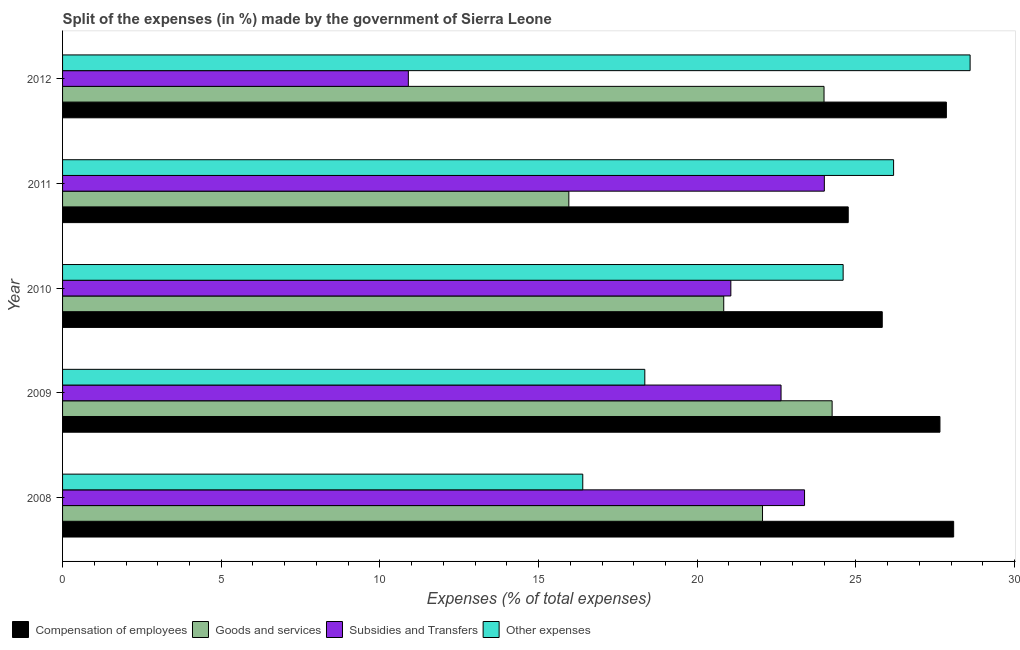How many bars are there on the 2nd tick from the bottom?
Give a very brief answer. 4. What is the label of the 2nd group of bars from the top?
Your answer should be compact. 2011. In how many cases, is the number of bars for a given year not equal to the number of legend labels?
Your answer should be compact. 0. What is the percentage of amount spent on other expenses in 2011?
Offer a terse response. 26.19. Across all years, what is the maximum percentage of amount spent on goods and services?
Your answer should be compact. 24.25. Across all years, what is the minimum percentage of amount spent on other expenses?
Your answer should be very brief. 16.39. In which year was the percentage of amount spent on compensation of employees maximum?
Offer a very short reply. 2008. What is the total percentage of amount spent on compensation of employees in the graph?
Give a very brief answer. 134.17. What is the difference between the percentage of amount spent on subsidies in 2010 and that in 2011?
Offer a very short reply. -2.95. What is the difference between the percentage of amount spent on other expenses in 2009 and the percentage of amount spent on goods and services in 2011?
Keep it short and to the point. 2.39. What is the average percentage of amount spent on goods and services per year?
Keep it short and to the point. 21.42. In the year 2008, what is the difference between the percentage of amount spent on compensation of employees and percentage of amount spent on subsidies?
Provide a short and direct response. 4.7. In how many years, is the percentage of amount spent on subsidies greater than 7 %?
Make the answer very short. 5. What is the ratio of the percentage of amount spent on other expenses in 2008 to that in 2009?
Give a very brief answer. 0.89. Is the difference between the percentage of amount spent on goods and services in 2008 and 2012 greater than the difference between the percentage of amount spent on compensation of employees in 2008 and 2012?
Offer a very short reply. No. What is the difference between the highest and the second highest percentage of amount spent on other expenses?
Offer a very short reply. 2.41. Is the sum of the percentage of amount spent on subsidies in 2008 and 2011 greater than the maximum percentage of amount spent on compensation of employees across all years?
Ensure brevity in your answer.  Yes. Is it the case that in every year, the sum of the percentage of amount spent on compensation of employees and percentage of amount spent on other expenses is greater than the sum of percentage of amount spent on goods and services and percentage of amount spent on subsidies?
Offer a terse response. No. What does the 4th bar from the top in 2012 represents?
Keep it short and to the point. Compensation of employees. What does the 4th bar from the bottom in 2012 represents?
Provide a short and direct response. Other expenses. How many bars are there?
Offer a very short reply. 20. How many years are there in the graph?
Offer a terse response. 5. Are the values on the major ticks of X-axis written in scientific E-notation?
Give a very brief answer. No. Does the graph contain any zero values?
Keep it short and to the point. No. Does the graph contain grids?
Your answer should be very brief. No. Where does the legend appear in the graph?
Provide a succinct answer. Bottom left. How are the legend labels stacked?
Offer a very short reply. Horizontal. What is the title of the graph?
Provide a succinct answer. Split of the expenses (in %) made by the government of Sierra Leone. Does "Iceland" appear as one of the legend labels in the graph?
Your answer should be compact. No. What is the label or title of the X-axis?
Provide a short and direct response. Expenses (% of total expenses). What is the label or title of the Y-axis?
Provide a succinct answer. Year. What is the Expenses (% of total expenses) of Compensation of employees in 2008?
Your answer should be compact. 28.08. What is the Expenses (% of total expenses) of Goods and services in 2008?
Offer a very short reply. 22.06. What is the Expenses (% of total expenses) in Subsidies and Transfers in 2008?
Offer a terse response. 23.38. What is the Expenses (% of total expenses) of Other expenses in 2008?
Your answer should be compact. 16.39. What is the Expenses (% of total expenses) of Compensation of employees in 2009?
Offer a terse response. 27.65. What is the Expenses (% of total expenses) of Goods and services in 2009?
Make the answer very short. 24.25. What is the Expenses (% of total expenses) of Subsidies and Transfers in 2009?
Your answer should be very brief. 22.64. What is the Expenses (% of total expenses) of Other expenses in 2009?
Your answer should be compact. 18.35. What is the Expenses (% of total expenses) of Compensation of employees in 2010?
Offer a terse response. 25.83. What is the Expenses (% of total expenses) in Goods and services in 2010?
Give a very brief answer. 20.84. What is the Expenses (% of total expenses) of Subsidies and Transfers in 2010?
Your response must be concise. 21.06. What is the Expenses (% of total expenses) in Other expenses in 2010?
Your answer should be very brief. 24.6. What is the Expenses (% of total expenses) in Compensation of employees in 2011?
Offer a terse response. 24.76. What is the Expenses (% of total expenses) of Goods and services in 2011?
Offer a terse response. 15.95. What is the Expenses (% of total expenses) in Subsidies and Transfers in 2011?
Offer a terse response. 24.01. What is the Expenses (% of total expenses) in Other expenses in 2011?
Keep it short and to the point. 26.19. What is the Expenses (% of total expenses) in Compensation of employees in 2012?
Your answer should be compact. 27.85. What is the Expenses (% of total expenses) of Goods and services in 2012?
Make the answer very short. 24. What is the Expenses (% of total expenses) in Subsidies and Transfers in 2012?
Offer a terse response. 10.9. What is the Expenses (% of total expenses) in Other expenses in 2012?
Make the answer very short. 28.6. Across all years, what is the maximum Expenses (% of total expenses) in Compensation of employees?
Your response must be concise. 28.08. Across all years, what is the maximum Expenses (% of total expenses) in Goods and services?
Provide a short and direct response. 24.25. Across all years, what is the maximum Expenses (% of total expenses) of Subsidies and Transfers?
Your answer should be very brief. 24.01. Across all years, what is the maximum Expenses (% of total expenses) in Other expenses?
Ensure brevity in your answer.  28.6. Across all years, what is the minimum Expenses (% of total expenses) of Compensation of employees?
Your answer should be very brief. 24.76. Across all years, what is the minimum Expenses (% of total expenses) of Goods and services?
Your answer should be very brief. 15.95. Across all years, what is the minimum Expenses (% of total expenses) in Subsidies and Transfers?
Provide a succinct answer. 10.9. Across all years, what is the minimum Expenses (% of total expenses) in Other expenses?
Your response must be concise. 16.39. What is the total Expenses (% of total expenses) of Compensation of employees in the graph?
Keep it short and to the point. 134.17. What is the total Expenses (% of total expenses) in Goods and services in the graph?
Provide a succinct answer. 107.09. What is the total Expenses (% of total expenses) in Subsidies and Transfers in the graph?
Your answer should be compact. 101.99. What is the total Expenses (% of total expenses) in Other expenses in the graph?
Offer a very short reply. 114.13. What is the difference between the Expenses (% of total expenses) in Compensation of employees in 2008 and that in 2009?
Give a very brief answer. 0.43. What is the difference between the Expenses (% of total expenses) of Goods and services in 2008 and that in 2009?
Ensure brevity in your answer.  -2.19. What is the difference between the Expenses (% of total expenses) in Subsidies and Transfers in 2008 and that in 2009?
Your answer should be compact. 0.74. What is the difference between the Expenses (% of total expenses) of Other expenses in 2008 and that in 2009?
Make the answer very short. -1.96. What is the difference between the Expenses (% of total expenses) of Compensation of employees in 2008 and that in 2010?
Make the answer very short. 2.25. What is the difference between the Expenses (% of total expenses) of Goods and services in 2008 and that in 2010?
Make the answer very short. 1.22. What is the difference between the Expenses (% of total expenses) in Subsidies and Transfers in 2008 and that in 2010?
Offer a very short reply. 2.32. What is the difference between the Expenses (% of total expenses) of Other expenses in 2008 and that in 2010?
Your response must be concise. -8.21. What is the difference between the Expenses (% of total expenses) in Compensation of employees in 2008 and that in 2011?
Make the answer very short. 3.32. What is the difference between the Expenses (% of total expenses) of Goods and services in 2008 and that in 2011?
Keep it short and to the point. 6.1. What is the difference between the Expenses (% of total expenses) in Subsidies and Transfers in 2008 and that in 2011?
Keep it short and to the point. -0.62. What is the difference between the Expenses (% of total expenses) of Other expenses in 2008 and that in 2011?
Give a very brief answer. -9.8. What is the difference between the Expenses (% of total expenses) of Compensation of employees in 2008 and that in 2012?
Your response must be concise. 0.23. What is the difference between the Expenses (% of total expenses) in Goods and services in 2008 and that in 2012?
Provide a short and direct response. -1.94. What is the difference between the Expenses (% of total expenses) of Subsidies and Transfers in 2008 and that in 2012?
Keep it short and to the point. 12.49. What is the difference between the Expenses (% of total expenses) in Other expenses in 2008 and that in 2012?
Your response must be concise. -12.21. What is the difference between the Expenses (% of total expenses) of Compensation of employees in 2009 and that in 2010?
Offer a terse response. 1.82. What is the difference between the Expenses (% of total expenses) of Goods and services in 2009 and that in 2010?
Ensure brevity in your answer.  3.42. What is the difference between the Expenses (% of total expenses) of Subsidies and Transfers in 2009 and that in 2010?
Your answer should be compact. 1.58. What is the difference between the Expenses (% of total expenses) in Other expenses in 2009 and that in 2010?
Make the answer very short. -6.25. What is the difference between the Expenses (% of total expenses) in Compensation of employees in 2009 and that in 2011?
Provide a succinct answer. 2.89. What is the difference between the Expenses (% of total expenses) of Goods and services in 2009 and that in 2011?
Offer a terse response. 8.3. What is the difference between the Expenses (% of total expenses) in Subsidies and Transfers in 2009 and that in 2011?
Keep it short and to the point. -1.36. What is the difference between the Expenses (% of total expenses) in Other expenses in 2009 and that in 2011?
Offer a very short reply. -7.84. What is the difference between the Expenses (% of total expenses) in Compensation of employees in 2009 and that in 2012?
Your response must be concise. -0.2. What is the difference between the Expenses (% of total expenses) of Goods and services in 2009 and that in 2012?
Your response must be concise. 0.25. What is the difference between the Expenses (% of total expenses) in Subsidies and Transfers in 2009 and that in 2012?
Offer a terse response. 11.74. What is the difference between the Expenses (% of total expenses) in Other expenses in 2009 and that in 2012?
Provide a short and direct response. -10.25. What is the difference between the Expenses (% of total expenses) in Compensation of employees in 2010 and that in 2011?
Provide a succinct answer. 1.07. What is the difference between the Expenses (% of total expenses) of Goods and services in 2010 and that in 2011?
Offer a terse response. 4.88. What is the difference between the Expenses (% of total expenses) in Subsidies and Transfers in 2010 and that in 2011?
Your answer should be compact. -2.95. What is the difference between the Expenses (% of total expenses) of Other expenses in 2010 and that in 2011?
Offer a terse response. -1.59. What is the difference between the Expenses (% of total expenses) in Compensation of employees in 2010 and that in 2012?
Ensure brevity in your answer.  -2.02. What is the difference between the Expenses (% of total expenses) in Goods and services in 2010 and that in 2012?
Your answer should be compact. -3.16. What is the difference between the Expenses (% of total expenses) of Subsidies and Transfers in 2010 and that in 2012?
Your answer should be very brief. 10.16. What is the difference between the Expenses (% of total expenses) in Other expenses in 2010 and that in 2012?
Make the answer very short. -4. What is the difference between the Expenses (% of total expenses) in Compensation of employees in 2011 and that in 2012?
Your response must be concise. -3.09. What is the difference between the Expenses (% of total expenses) of Goods and services in 2011 and that in 2012?
Your answer should be compact. -8.04. What is the difference between the Expenses (% of total expenses) of Subsidies and Transfers in 2011 and that in 2012?
Your answer should be compact. 13.11. What is the difference between the Expenses (% of total expenses) in Other expenses in 2011 and that in 2012?
Offer a very short reply. -2.41. What is the difference between the Expenses (% of total expenses) of Compensation of employees in 2008 and the Expenses (% of total expenses) of Goods and services in 2009?
Provide a short and direct response. 3.83. What is the difference between the Expenses (% of total expenses) of Compensation of employees in 2008 and the Expenses (% of total expenses) of Subsidies and Transfers in 2009?
Provide a succinct answer. 5.44. What is the difference between the Expenses (% of total expenses) of Compensation of employees in 2008 and the Expenses (% of total expenses) of Other expenses in 2009?
Make the answer very short. 9.73. What is the difference between the Expenses (% of total expenses) of Goods and services in 2008 and the Expenses (% of total expenses) of Subsidies and Transfers in 2009?
Your response must be concise. -0.58. What is the difference between the Expenses (% of total expenses) of Goods and services in 2008 and the Expenses (% of total expenses) of Other expenses in 2009?
Offer a terse response. 3.71. What is the difference between the Expenses (% of total expenses) in Subsidies and Transfers in 2008 and the Expenses (% of total expenses) in Other expenses in 2009?
Keep it short and to the point. 5.03. What is the difference between the Expenses (% of total expenses) in Compensation of employees in 2008 and the Expenses (% of total expenses) in Goods and services in 2010?
Your answer should be compact. 7.25. What is the difference between the Expenses (% of total expenses) in Compensation of employees in 2008 and the Expenses (% of total expenses) in Subsidies and Transfers in 2010?
Give a very brief answer. 7.02. What is the difference between the Expenses (% of total expenses) in Compensation of employees in 2008 and the Expenses (% of total expenses) in Other expenses in 2010?
Provide a succinct answer. 3.48. What is the difference between the Expenses (% of total expenses) of Goods and services in 2008 and the Expenses (% of total expenses) of Subsidies and Transfers in 2010?
Provide a short and direct response. 1. What is the difference between the Expenses (% of total expenses) in Goods and services in 2008 and the Expenses (% of total expenses) in Other expenses in 2010?
Offer a terse response. -2.54. What is the difference between the Expenses (% of total expenses) in Subsidies and Transfers in 2008 and the Expenses (% of total expenses) in Other expenses in 2010?
Keep it short and to the point. -1.22. What is the difference between the Expenses (% of total expenses) in Compensation of employees in 2008 and the Expenses (% of total expenses) in Goods and services in 2011?
Your answer should be compact. 12.13. What is the difference between the Expenses (% of total expenses) in Compensation of employees in 2008 and the Expenses (% of total expenses) in Subsidies and Transfers in 2011?
Your answer should be very brief. 4.08. What is the difference between the Expenses (% of total expenses) in Compensation of employees in 2008 and the Expenses (% of total expenses) in Other expenses in 2011?
Your response must be concise. 1.89. What is the difference between the Expenses (% of total expenses) in Goods and services in 2008 and the Expenses (% of total expenses) in Subsidies and Transfers in 2011?
Your answer should be compact. -1.95. What is the difference between the Expenses (% of total expenses) of Goods and services in 2008 and the Expenses (% of total expenses) of Other expenses in 2011?
Your answer should be compact. -4.13. What is the difference between the Expenses (% of total expenses) of Subsidies and Transfers in 2008 and the Expenses (% of total expenses) of Other expenses in 2011?
Your response must be concise. -2.81. What is the difference between the Expenses (% of total expenses) of Compensation of employees in 2008 and the Expenses (% of total expenses) of Goods and services in 2012?
Offer a very short reply. 4.08. What is the difference between the Expenses (% of total expenses) of Compensation of employees in 2008 and the Expenses (% of total expenses) of Subsidies and Transfers in 2012?
Your answer should be compact. 17.18. What is the difference between the Expenses (% of total expenses) in Compensation of employees in 2008 and the Expenses (% of total expenses) in Other expenses in 2012?
Ensure brevity in your answer.  -0.52. What is the difference between the Expenses (% of total expenses) of Goods and services in 2008 and the Expenses (% of total expenses) of Subsidies and Transfers in 2012?
Give a very brief answer. 11.16. What is the difference between the Expenses (% of total expenses) in Goods and services in 2008 and the Expenses (% of total expenses) in Other expenses in 2012?
Provide a succinct answer. -6.54. What is the difference between the Expenses (% of total expenses) of Subsidies and Transfers in 2008 and the Expenses (% of total expenses) of Other expenses in 2012?
Provide a succinct answer. -5.22. What is the difference between the Expenses (% of total expenses) of Compensation of employees in 2009 and the Expenses (% of total expenses) of Goods and services in 2010?
Provide a succinct answer. 6.81. What is the difference between the Expenses (% of total expenses) in Compensation of employees in 2009 and the Expenses (% of total expenses) in Subsidies and Transfers in 2010?
Your answer should be very brief. 6.59. What is the difference between the Expenses (% of total expenses) in Compensation of employees in 2009 and the Expenses (% of total expenses) in Other expenses in 2010?
Make the answer very short. 3.05. What is the difference between the Expenses (% of total expenses) in Goods and services in 2009 and the Expenses (% of total expenses) in Subsidies and Transfers in 2010?
Your response must be concise. 3.19. What is the difference between the Expenses (% of total expenses) in Goods and services in 2009 and the Expenses (% of total expenses) in Other expenses in 2010?
Give a very brief answer. -0.35. What is the difference between the Expenses (% of total expenses) of Subsidies and Transfers in 2009 and the Expenses (% of total expenses) of Other expenses in 2010?
Your response must be concise. -1.96. What is the difference between the Expenses (% of total expenses) of Compensation of employees in 2009 and the Expenses (% of total expenses) of Goods and services in 2011?
Provide a succinct answer. 11.7. What is the difference between the Expenses (% of total expenses) of Compensation of employees in 2009 and the Expenses (% of total expenses) of Subsidies and Transfers in 2011?
Offer a terse response. 3.64. What is the difference between the Expenses (% of total expenses) of Compensation of employees in 2009 and the Expenses (% of total expenses) of Other expenses in 2011?
Keep it short and to the point. 1.46. What is the difference between the Expenses (% of total expenses) in Goods and services in 2009 and the Expenses (% of total expenses) in Subsidies and Transfers in 2011?
Make the answer very short. 0.25. What is the difference between the Expenses (% of total expenses) in Goods and services in 2009 and the Expenses (% of total expenses) in Other expenses in 2011?
Offer a terse response. -1.94. What is the difference between the Expenses (% of total expenses) in Subsidies and Transfers in 2009 and the Expenses (% of total expenses) in Other expenses in 2011?
Keep it short and to the point. -3.55. What is the difference between the Expenses (% of total expenses) in Compensation of employees in 2009 and the Expenses (% of total expenses) in Goods and services in 2012?
Keep it short and to the point. 3.65. What is the difference between the Expenses (% of total expenses) in Compensation of employees in 2009 and the Expenses (% of total expenses) in Subsidies and Transfers in 2012?
Give a very brief answer. 16.75. What is the difference between the Expenses (% of total expenses) of Compensation of employees in 2009 and the Expenses (% of total expenses) of Other expenses in 2012?
Provide a succinct answer. -0.95. What is the difference between the Expenses (% of total expenses) of Goods and services in 2009 and the Expenses (% of total expenses) of Subsidies and Transfers in 2012?
Your answer should be very brief. 13.35. What is the difference between the Expenses (% of total expenses) of Goods and services in 2009 and the Expenses (% of total expenses) of Other expenses in 2012?
Provide a short and direct response. -4.35. What is the difference between the Expenses (% of total expenses) of Subsidies and Transfers in 2009 and the Expenses (% of total expenses) of Other expenses in 2012?
Keep it short and to the point. -5.96. What is the difference between the Expenses (% of total expenses) of Compensation of employees in 2010 and the Expenses (% of total expenses) of Goods and services in 2011?
Provide a succinct answer. 9.88. What is the difference between the Expenses (% of total expenses) of Compensation of employees in 2010 and the Expenses (% of total expenses) of Subsidies and Transfers in 2011?
Your response must be concise. 1.82. What is the difference between the Expenses (% of total expenses) in Compensation of employees in 2010 and the Expenses (% of total expenses) in Other expenses in 2011?
Your answer should be very brief. -0.36. What is the difference between the Expenses (% of total expenses) in Goods and services in 2010 and the Expenses (% of total expenses) in Subsidies and Transfers in 2011?
Provide a short and direct response. -3.17. What is the difference between the Expenses (% of total expenses) of Goods and services in 2010 and the Expenses (% of total expenses) of Other expenses in 2011?
Your response must be concise. -5.35. What is the difference between the Expenses (% of total expenses) in Subsidies and Transfers in 2010 and the Expenses (% of total expenses) in Other expenses in 2011?
Provide a short and direct response. -5.13. What is the difference between the Expenses (% of total expenses) in Compensation of employees in 2010 and the Expenses (% of total expenses) in Goods and services in 2012?
Your answer should be compact. 1.83. What is the difference between the Expenses (% of total expenses) in Compensation of employees in 2010 and the Expenses (% of total expenses) in Subsidies and Transfers in 2012?
Ensure brevity in your answer.  14.93. What is the difference between the Expenses (% of total expenses) of Compensation of employees in 2010 and the Expenses (% of total expenses) of Other expenses in 2012?
Give a very brief answer. -2.77. What is the difference between the Expenses (% of total expenses) in Goods and services in 2010 and the Expenses (% of total expenses) in Subsidies and Transfers in 2012?
Offer a terse response. 9.94. What is the difference between the Expenses (% of total expenses) in Goods and services in 2010 and the Expenses (% of total expenses) in Other expenses in 2012?
Offer a very short reply. -7.76. What is the difference between the Expenses (% of total expenses) in Subsidies and Transfers in 2010 and the Expenses (% of total expenses) in Other expenses in 2012?
Your answer should be very brief. -7.54. What is the difference between the Expenses (% of total expenses) of Compensation of employees in 2011 and the Expenses (% of total expenses) of Goods and services in 2012?
Provide a short and direct response. 0.76. What is the difference between the Expenses (% of total expenses) in Compensation of employees in 2011 and the Expenses (% of total expenses) in Subsidies and Transfers in 2012?
Your answer should be very brief. 13.86. What is the difference between the Expenses (% of total expenses) of Compensation of employees in 2011 and the Expenses (% of total expenses) of Other expenses in 2012?
Offer a very short reply. -3.84. What is the difference between the Expenses (% of total expenses) of Goods and services in 2011 and the Expenses (% of total expenses) of Subsidies and Transfers in 2012?
Keep it short and to the point. 5.06. What is the difference between the Expenses (% of total expenses) in Goods and services in 2011 and the Expenses (% of total expenses) in Other expenses in 2012?
Your response must be concise. -12.65. What is the difference between the Expenses (% of total expenses) of Subsidies and Transfers in 2011 and the Expenses (% of total expenses) of Other expenses in 2012?
Make the answer very short. -4.59. What is the average Expenses (% of total expenses) of Compensation of employees per year?
Keep it short and to the point. 26.83. What is the average Expenses (% of total expenses) in Goods and services per year?
Make the answer very short. 21.42. What is the average Expenses (% of total expenses) in Subsidies and Transfers per year?
Your answer should be very brief. 20.4. What is the average Expenses (% of total expenses) of Other expenses per year?
Make the answer very short. 22.83. In the year 2008, what is the difference between the Expenses (% of total expenses) of Compensation of employees and Expenses (% of total expenses) of Goods and services?
Make the answer very short. 6.02. In the year 2008, what is the difference between the Expenses (% of total expenses) of Compensation of employees and Expenses (% of total expenses) of Subsidies and Transfers?
Your answer should be compact. 4.7. In the year 2008, what is the difference between the Expenses (% of total expenses) of Compensation of employees and Expenses (% of total expenses) of Other expenses?
Ensure brevity in your answer.  11.69. In the year 2008, what is the difference between the Expenses (% of total expenses) in Goods and services and Expenses (% of total expenses) in Subsidies and Transfers?
Keep it short and to the point. -1.32. In the year 2008, what is the difference between the Expenses (% of total expenses) in Goods and services and Expenses (% of total expenses) in Other expenses?
Keep it short and to the point. 5.66. In the year 2008, what is the difference between the Expenses (% of total expenses) in Subsidies and Transfers and Expenses (% of total expenses) in Other expenses?
Give a very brief answer. 6.99. In the year 2009, what is the difference between the Expenses (% of total expenses) in Compensation of employees and Expenses (% of total expenses) in Goods and services?
Your answer should be very brief. 3.4. In the year 2009, what is the difference between the Expenses (% of total expenses) in Compensation of employees and Expenses (% of total expenses) in Subsidies and Transfers?
Give a very brief answer. 5.01. In the year 2009, what is the difference between the Expenses (% of total expenses) of Compensation of employees and Expenses (% of total expenses) of Other expenses?
Offer a terse response. 9.3. In the year 2009, what is the difference between the Expenses (% of total expenses) of Goods and services and Expenses (% of total expenses) of Subsidies and Transfers?
Provide a succinct answer. 1.61. In the year 2009, what is the difference between the Expenses (% of total expenses) of Goods and services and Expenses (% of total expenses) of Other expenses?
Your response must be concise. 5.9. In the year 2009, what is the difference between the Expenses (% of total expenses) in Subsidies and Transfers and Expenses (% of total expenses) in Other expenses?
Provide a succinct answer. 4.29. In the year 2010, what is the difference between the Expenses (% of total expenses) in Compensation of employees and Expenses (% of total expenses) in Goods and services?
Offer a terse response. 5. In the year 2010, what is the difference between the Expenses (% of total expenses) in Compensation of employees and Expenses (% of total expenses) in Subsidies and Transfers?
Your response must be concise. 4.77. In the year 2010, what is the difference between the Expenses (% of total expenses) of Compensation of employees and Expenses (% of total expenses) of Other expenses?
Make the answer very short. 1.23. In the year 2010, what is the difference between the Expenses (% of total expenses) of Goods and services and Expenses (% of total expenses) of Subsidies and Transfers?
Offer a terse response. -0.22. In the year 2010, what is the difference between the Expenses (% of total expenses) of Goods and services and Expenses (% of total expenses) of Other expenses?
Your answer should be compact. -3.76. In the year 2010, what is the difference between the Expenses (% of total expenses) in Subsidies and Transfers and Expenses (% of total expenses) in Other expenses?
Your response must be concise. -3.54. In the year 2011, what is the difference between the Expenses (% of total expenses) in Compensation of employees and Expenses (% of total expenses) in Goods and services?
Your response must be concise. 8.8. In the year 2011, what is the difference between the Expenses (% of total expenses) of Compensation of employees and Expenses (% of total expenses) of Subsidies and Transfers?
Your response must be concise. 0.75. In the year 2011, what is the difference between the Expenses (% of total expenses) of Compensation of employees and Expenses (% of total expenses) of Other expenses?
Offer a terse response. -1.43. In the year 2011, what is the difference between the Expenses (% of total expenses) in Goods and services and Expenses (% of total expenses) in Subsidies and Transfers?
Offer a terse response. -8.05. In the year 2011, what is the difference between the Expenses (% of total expenses) in Goods and services and Expenses (% of total expenses) in Other expenses?
Your response must be concise. -10.23. In the year 2011, what is the difference between the Expenses (% of total expenses) of Subsidies and Transfers and Expenses (% of total expenses) of Other expenses?
Provide a short and direct response. -2.18. In the year 2012, what is the difference between the Expenses (% of total expenses) of Compensation of employees and Expenses (% of total expenses) of Goods and services?
Your response must be concise. 3.86. In the year 2012, what is the difference between the Expenses (% of total expenses) of Compensation of employees and Expenses (% of total expenses) of Subsidies and Transfers?
Keep it short and to the point. 16.95. In the year 2012, what is the difference between the Expenses (% of total expenses) of Compensation of employees and Expenses (% of total expenses) of Other expenses?
Offer a terse response. -0.75. In the year 2012, what is the difference between the Expenses (% of total expenses) in Goods and services and Expenses (% of total expenses) in Subsidies and Transfers?
Make the answer very short. 13.1. In the year 2012, what is the difference between the Expenses (% of total expenses) in Goods and services and Expenses (% of total expenses) in Other expenses?
Your answer should be very brief. -4.6. In the year 2012, what is the difference between the Expenses (% of total expenses) in Subsidies and Transfers and Expenses (% of total expenses) in Other expenses?
Give a very brief answer. -17.7. What is the ratio of the Expenses (% of total expenses) of Compensation of employees in 2008 to that in 2009?
Make the answer very short. 1.02. What is the ratio of the Expenses (% of total expenses) in Goods and services in 2008 to that in 2009?
Make the answer very short. 0.91. What is the ratio of the Expenses (% of total expenses) in Subsidies and Transfers in 2008 to that in 2009?
Your response must be concise. 1.03. What is the ratio of the Expenses (% of total expenses) of Other expenses in 2008 to that in 2009?
Make the answer very short. 0.89. What is the ratio of the Expenses (% of total expenses) in Compensation of employees in 2008 to that in 2010?
Provide a succinct answer. 1.09. What is the ratio of the Expenses (% of total expenses) in Goods and services in 2008 to that in 2010?
Your answer should be very brief. 1.06. What is the ratio of the Expenses (% of total expenses) in Subsidies and Transfers in 2008 to that in 2010?
Provide a short and direct response. 1.11. What is the ratio of the Expenses (% of total expenses) of Other expenses in 2008 to that in 2010?
Keep it short and to the point. 0.67. What is the ratio of the Expenses (% of total expenses) in Compensation of employees in 2008 to that in 2011?
Provide a succinct answer. 1.13. What is the ratio of the Expenses (% of total expenses) in Goods and services in 2008 to that in 2011?
Your response must be concise. 1.38. What is the ratio of the Expenses (% of total expenses) in Other expenses in 2008 to that in 2011?
Provide a succinct answer. 0.63. What is the ratio of the Expenses (% of total expenses) in Compensation of employees in 2008 to that in 2012?
Offer a very short reply. 1.01. What is the ratio of the Expenses (% of total expenses) of Goods and services in 2008 to that in 2012?
Give a very brief answer. 0.92. What is the ratio of the Expenses (% of total expenses) of Subsidies and Transfers in 2008 to that in 2012?
Provide a short and direct response. 2.15. What is the ratio of the Expenses (% of total expenses) of Other expenses in 2008 to that in 2012?
Provide a short and direct response. 0.57. What is the ratio of the Expenses (% of total expenses) of Compensation of employees in 2009 to that in 2010?
Your response must be concise. 1.07. What is the ratio of the Expenses (% of total expenses) in Goods and services in 2009 to that in 2010?
Offer a terse response. 1.16. What is the ratio of the Expenses (% of total expenses) of Subsidies and Transfers in 2009 to that in 2010?
Your response must be concise. 1.08. What is the ratio of the Expenses (% of total expenses) in Other expenses in 2009 to that in 2010?
Provide a succinct answer. 0.75. What is the ratio of the Expenses (% of total expenses) in Compensation of employees in 2009 to that in 2011?
Provide a succinct answer. 1.12. What is the ratio of the Expenses (% of total expenses) of Goods and services in 2009 to that in 2011?
Offer a very short reply. 1.52. What is the ratio of the Expenses (% of total expenses) in Subsidies and Transfers in 2009 to that in 2011?
Provide a short and direct response. 0.94. What is the ratio of the Expenses (% of total expenses) in Other expenses in 2009 to that in 2011?
Provide a short and direct response. 0.7. What is the ratio of the Expenses (% of total expenses) of Compensation of employees in 2009 to that in 2012?
Give a very brief answer. 0.99. What is the ratio of the Expenses (% of total expenses) in Goods and services in 2009 to that in 2012?
Offer a very short reply. 1.01. What is the ratio of the Expenses (% of total expenses) of Subsidies and Transfers in 2009 to that in 2012?
Provide a succinct answer. 2.08. What is the ratio of the Expenses (% of total expenses) of Other expenses in 2009 to that in 2012?
Keep it short and to the point. 0.64. What is the ratio of the Expenses (% of total expenses) in Compensation of employees in 2010 to that in 2011?
Your answer should be compact. 1.04. What is the ratio of the Expenses (% of total expenses) in Goods and services in 2010 to that in 2011?
Offer a very short reply. 1.31. What is the ratio of the Expenses (% of total expenses) in Subsidies and Transfers in 2010 to that in 2011?
Your answer should be very brief. 0.88. What is the ratio of the Expenses (% of total expenses) of Other expenses in 2010 to that in 2011?
Your answer should be very brief. 0.94. What is the ratio of the Expenses (% of total expenses) of Compensation of employees in 2010 to that in 2012?
Offer a very short reply. 0.93. What is the ratio of the Expenses (% of total expenses) of Goods and services in 2010 to that in 2012?
Offer a terse response. 0.87. What is the ratio of the Expenses (% of total expenses) in Subsidies and Transfers in 2010 to that in 2012?
Offer a very short reply. 1.93. What is the ratio of the Expenses (% of total expenses) in Other expenses in 2010 to that in 2012?
Give a very brief answer. 0.86. What is the ratio of the Expenses (% of total expenses) of Compensation of employees in 2011 to that in 2012?
Make the answer very short. 0.89. What is the ratio of the Expenses (% of total expenses) of Goods and services in 2011 to that in 2012?
Your answer should be compact. 0.66. What is the ratio of the Expenses (% of total expenses) in Subsidies and Transfers in 2011 to that in 2012?
Keep it short and to the point. 2.2. What is the ratio of the Expenses (% of total expenses) in Other expenses in 2011 to that in 2012?
Your answer should be very brief. 0.92. What is the difference between the highest and the second highest Expenses (% of total expenses) in Compensation of employees?
Offer a terse response. 0.23. What is the difference between the highest and the second highest Expenses (% of total expenses) in Goods and services?
Give a very brief answer. 0.25. What is the difference between the highest and the second highest Expenses (% of total expenses) in Subsidies and Transfers?
Provide a short and direct response. 0.62. What is the difference between the highest and the second highest Expenses (% of total expenses) in Other expenses?
Your response must be concise. 2.41. What is the difference between the highest and the lowest Expenses (% of total expenses) of Compensation of employees?
Make the answer very short. 3.32. What is the difference between the highest and the lowest Expenses (% of total expenses) in Goods and services?
Your answer should be very brief. 8.3. What is the difference between the highest and the lowest Expenses (% of total expenses) in Subsidies and Transfers?
Give a very brief answer. 13.11. What is the difference between the highest and the lowest Expenses (% of total expenses) in Other expenses?
Your answer should be compact. 12.21. 